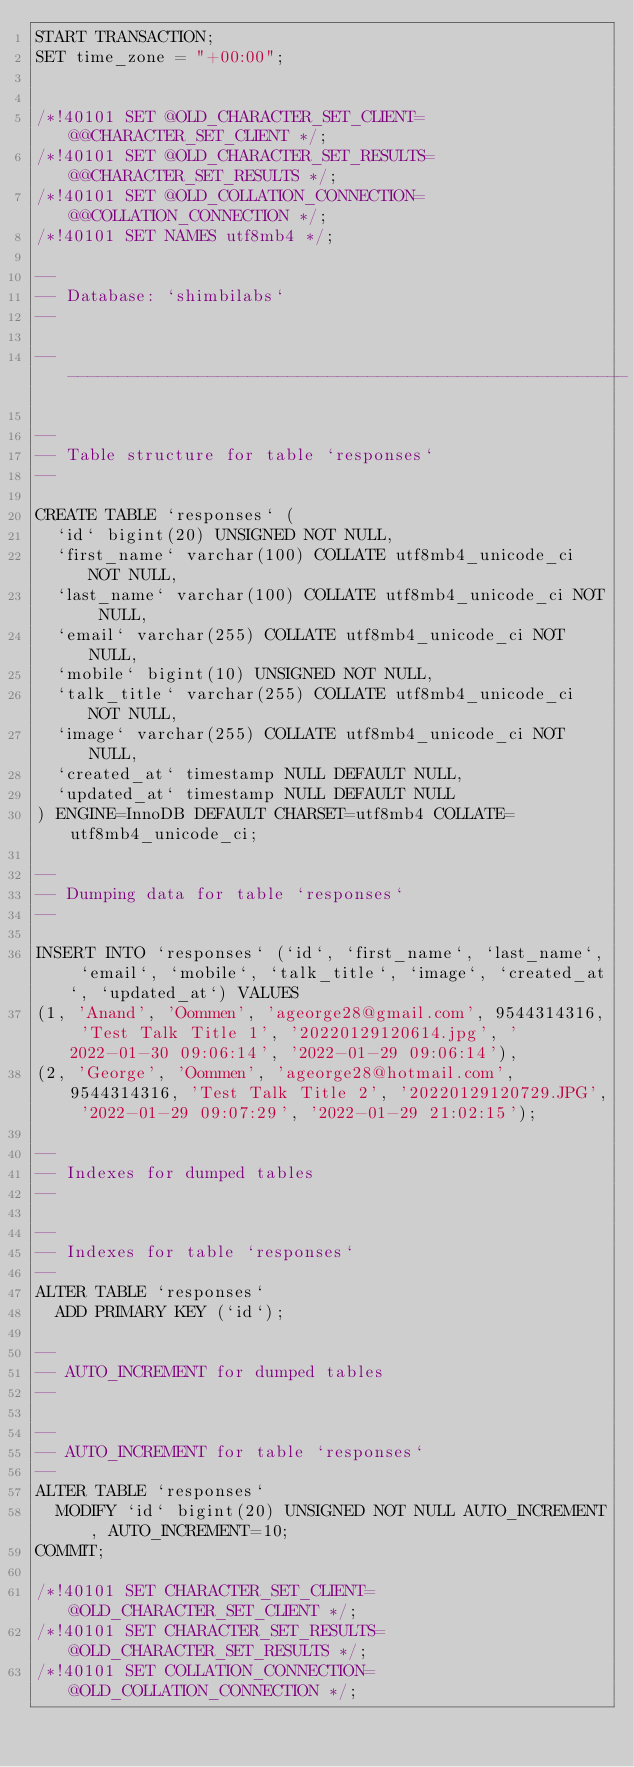<code> <loc_0><loc_0><loc_500><loc_500><_SQL_>START TRANSACTION;
SET time_zone = "+00:00";


/*!40101 SET @OLD_CHARACTER_SET_CLIENT=@@CHARACTER_SET_CLIENT */;
/*!40101 SET @OLD_CHARACTER_SET_RESULTS=@@CHARACTER_SET_RESULTS */;
/*!40101 SET @OLD_COLLATION_CONNECTION=@@COLLATION_CONNECTION */;
/*!40101 SET NAMES utf8mb4 */;

--
-- Database: `shimbilabs`
--

-- --------------------------------------------------------

--
-- Table structure for table `responses`
--

CREATE TABLE `responses` (
  `id` bigint(20) UNSIGNED NOT NULL,
  `first_name` varchar(100) COLLATE utf8mb4_unicode_ci NOT NULL,
  `last_name` varchar(100) COLLATE utf8mb4_unicode_ci NOT NULL,
  `email` varchar(255) COLLATE utf8mb4_unicode_ci NOT NULL,
  `mobile` bigint(10) UNSIGNED NOT NULL,
  `talk_title` varchar(255) COLLATE utf8mb4_unicode_ci NOT NULL,
  `image` varchar(255) COLLATE utf8mb4_unicode_ci NOT NULL,
  `created_at` timestamp NULL DEFAULT NULL,
  `updated_at` timestamp NULL DEFAULT NULL
) ENGINE=InnoDB DEFAULT CHARSET=utf8mb4 COLLATE=utf8mb4_unicode_ci;

--
-- Dumping data for table `responses`
--

INSERT INTO `responses` (`id`, `first_name`, `last_name`, `email`, `mobile`, `talk_title`, `image`, `created_at`, `updated_at`) VALUES
(1, 'Anand', 'Oommen', 'ageorge28@gmail.com', 9544314316, 'Test Talk Title 1', '20220129120614.jpg', '2022-01-30 09:06:14', '2022-01-29 09:06:14'),
(2, 'George', 'Oommen', 'ageorge28@hotmail.com', 9544314316, 'Test Talk Title 2', '20220129120729.JPG', '2022-01-29 09:07:29', '2022-01-29 21:02:15');

--
-- Indexes for dumped tables
--

--
-- Indexes for table `responses`
--
ALTER TABLE `responses`
  ADD PRIMARY KEY (`id`);

--
-- AUTO_INCREMENT for dumped tables
--

--
-- AUTO_INCREMENT for table `responses`
--
ALTER TABLE `responses`
  MODIFY `id` bigint(20) UNSIGNED NOT NULL AUTO_INCREMENT, AUTO_INCREMENT=10;
COMMIT;

/*!40101 SET CHARACTER_SET_CLIENT=@OLD_CHARACTER_SET_CLIENT */;
/*!40101 SET CHARACTER_SET_RESULTS=@OLD_CHARACTER_SET_RESULTS */;
/*!40101 SET COLLATION_CONNECTION=@OLD_COLLATION_CONNECTION */;
</code> 